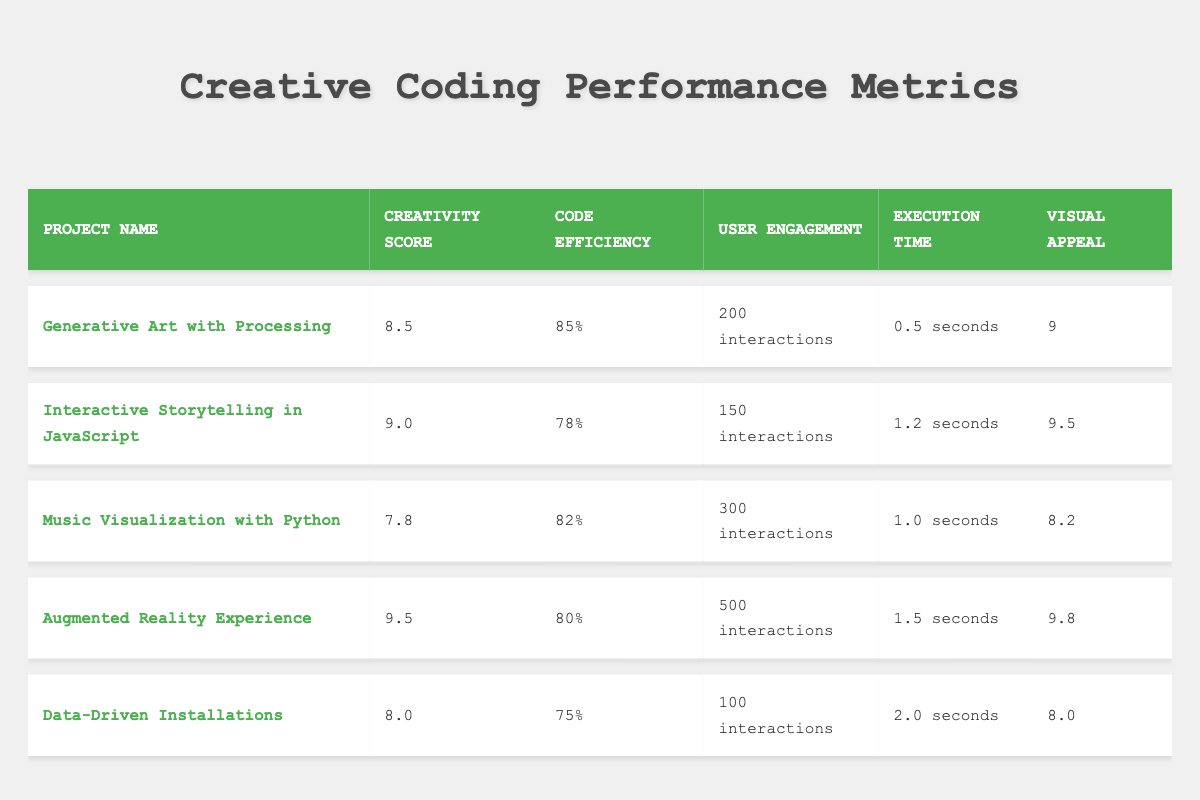What is the Creativity Score of "Interactive Storytelling in JavaScript"? The Creativity Score for "Interactive Storytelling in JavaScript" is clearly listed in the table under the appropriate column. Referring directly to the table, it reads 9.0.
Answer: 9.0 Which project has the highest User Engagement? To determine which project has the highest User Engagement, we compare the values listed in the User Engagement column. The highest number is 500 interactions, associated with the "Augmented Reality Experience".
Answer: Augmented Reality Experience What is the average Execution Time of all projects? First, we sum the Execution Times: 0.5 + 1.2 + 1.0 + 1.5 + 2.0 = 6.2 seconds. Next, we divide the total by the number of projects (5), so the average is 6.2 / 5 = 1.24 seconds.
Answer: 1.24 seconds Is the Code Efficiency of "Data-Driven Installations" higher than 80%? The Code Efficiency for "Data-Driven Installations" is listed as 75% in the table. Since 75% is less than 80%, the answer is no.
Answer: No How does the Visual Appeal of the project with the highest Creativity Score compare to the project with the lowest? The project with the highest Creativity Score is "Augmented Reality Experience" with a score of 9.5 in Visual Appeal. The project with the lowest Creativity Score is "Music Visualization with Python," which has a Visual Appeal score of 8.2. The difference in these scores is 9.5 - 8.2 = 1.3.
Answer: 1.3 What percentage of interactions does the "Generative Art with Processing" project have compared to the project with the highest User Engagement? The User Engagement for "Generative Art with Processing" is 200 interactions, while the project with the highest engagement, "Augmented Reality Experience," has 500 interactions. To find the percentage, (200 / 500) * 100 = 40%.
Answer: 40% 